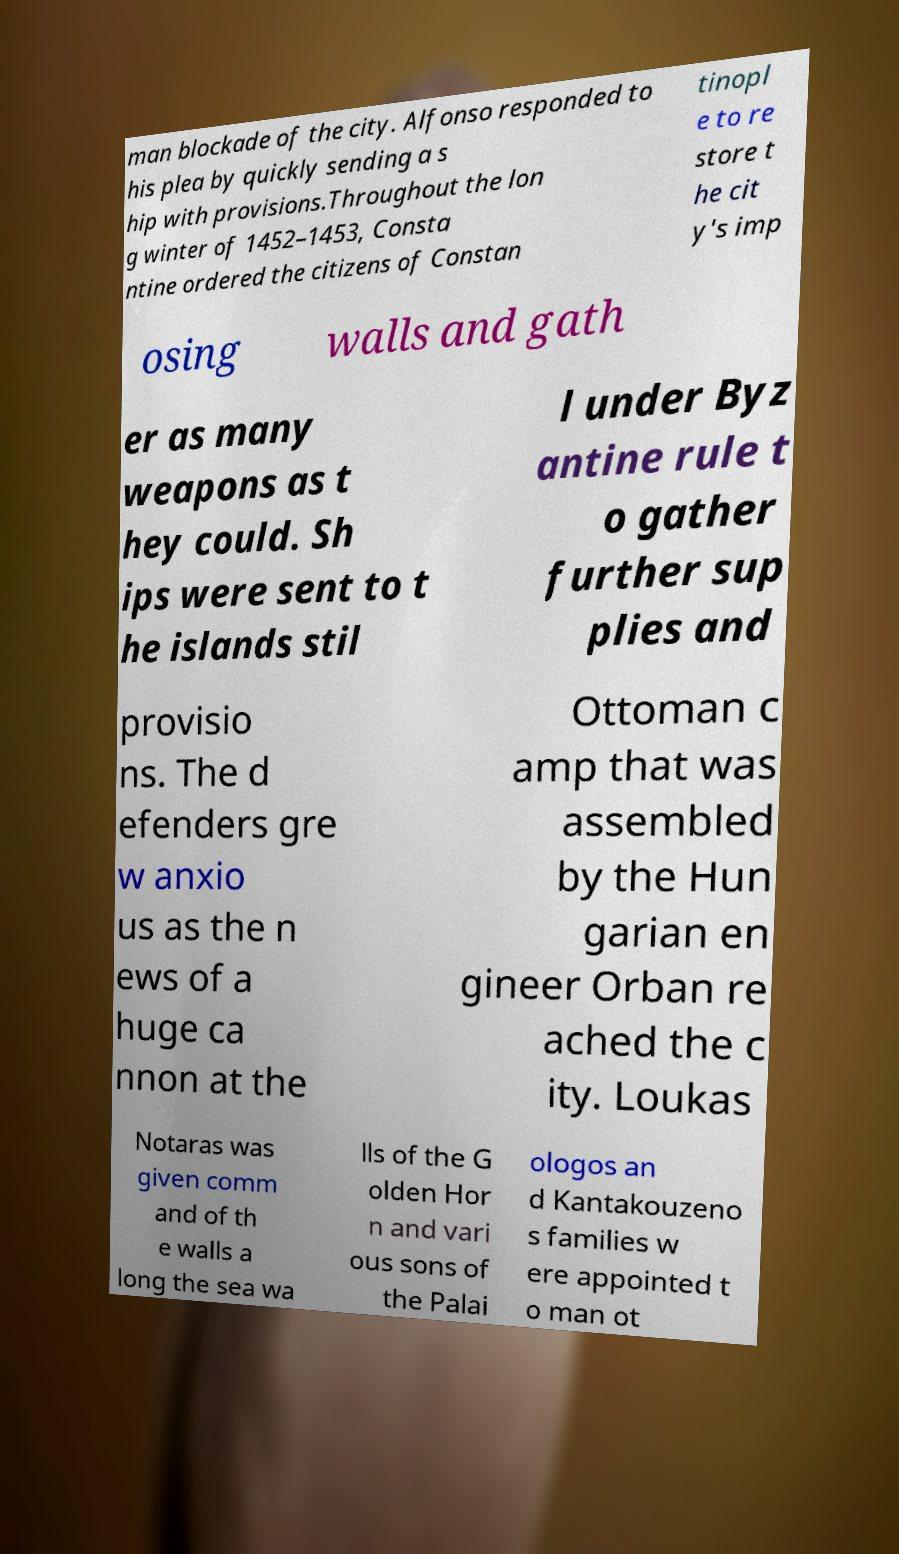Please read and relay the text visible in this image. What does it say? man blockade of the city. Alfonso responded to his plea by quickly sending a s hip with provisions.Throughout the lon g winter of 1452–1453, Consta ntine ordered the citizens of Constan tinopl e to re store t he cit y's imp osing walls and gath er as many weapons as t hey could. Sh ips were sent to t he islands stil l under Byz antine rule t o gather further sup plies and provisio ns. The d efenders gre w anxio us as the n ews of a huge ca nnon at the Ottoman c amp that was assembled by the Hun garian en gineer Orban re ached the c ity. Loukas Notaras was given comm and of th e walls a long the sea wa lls of the G olden Hor n and vari ous sons of the Palai ologos an d Kantakouzeno s families w ere appointed t o man ot 